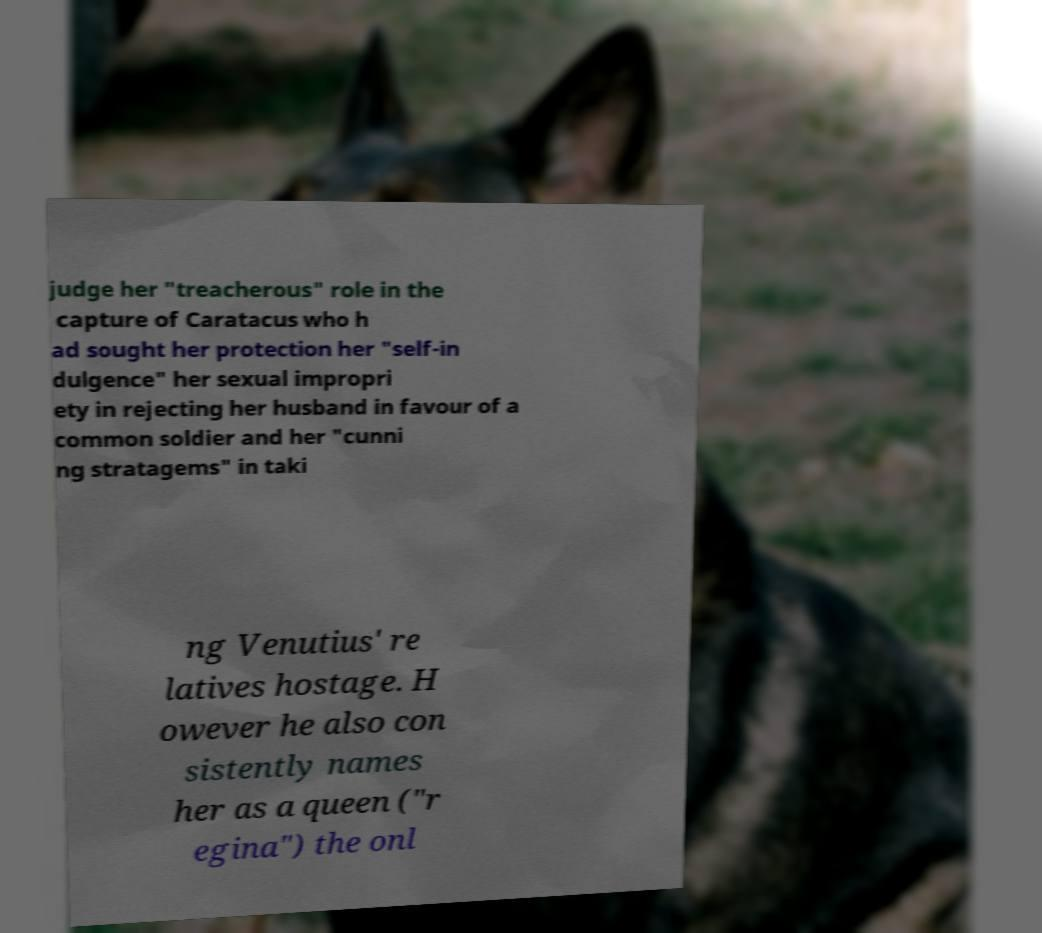For documentation purposes, I need the text within this image transcribed. Could you provide that? judge her "treacherous" role in the capture of Caratacus who h ad sought her protection her "self-in dulgence" her sexual impropri ety in rejecting her husband in favour of a common soldier and her "cunni ng stratagems" in taki ng Venutius' re latives hostage. H owever he also con sistently names her as a queen ("r egina") the onl 